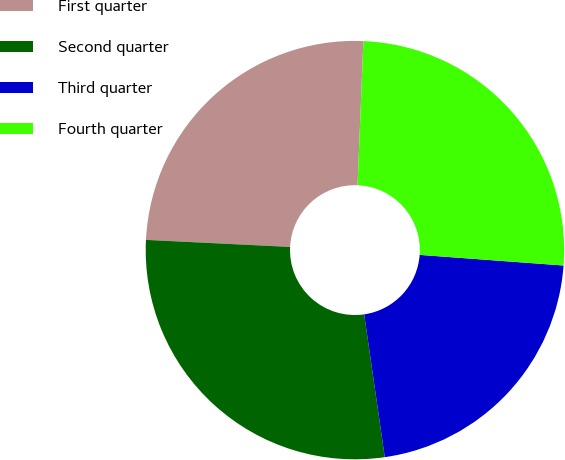<chart> <loc_0><loc_0><loc_500><loc_500><pie_chart><fcel>First quarter<fcel>Second quarter<fcel>Third quarter<fcel>Fourth quarter<nl><fcel>24.87%<fcel>28.06%<fcel>21.55%<fcel>25.53%<nl></chart> 